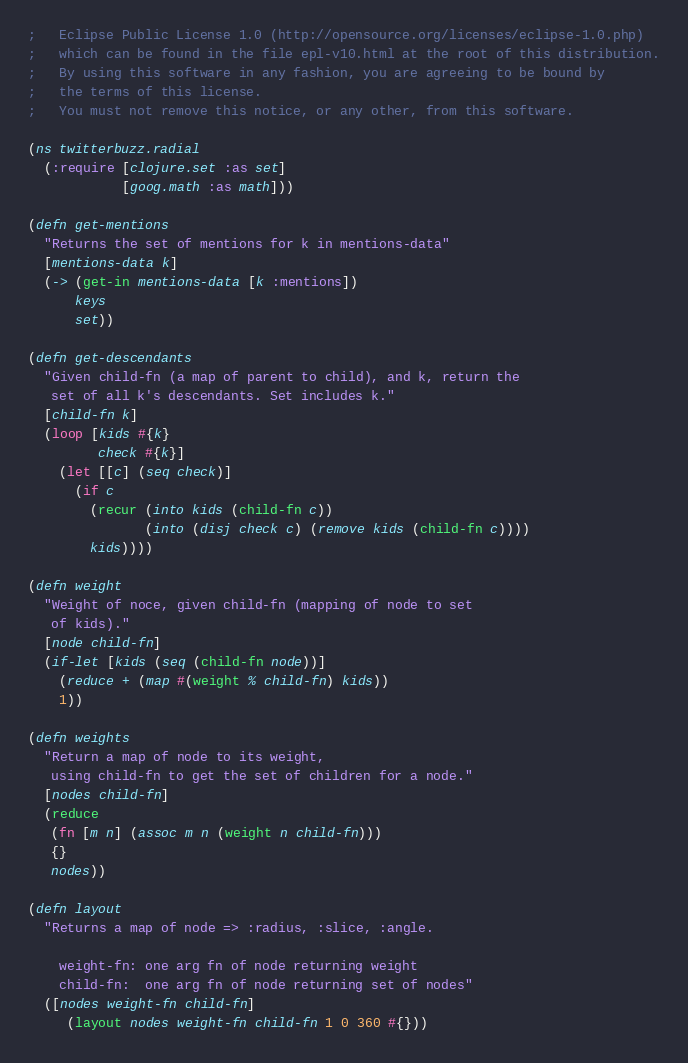Convert code to text. <code><loc_0><loc_0><loc_500><loc_500><_Clojure_>;   Eclipse Public License 1.0 (http://opensource.org/licenses/eclipse-1.0.php)
;   which can be found in the file epl-v10.html at the root of this distribution.
;   By using this software in any fashion, you are agreeing to be bound by
;   the terms of this license.
;   You must not remove this notice, or any other, from this software.

(ns twitterbuzz.radial
  (:require [clojure.set :as set]
            [goog.math :as math]))

(defn get-mentions
  "Returns the set of mentions for k in mentions-data"
  [mentions-data k]
  (-> (get-in mentions-data [k :mentions])
      keys
      set))

(defn get-descendants
  "Given child-fn (a map of parent to child), and k, return the
   set of all k's descendants. Set includes k."
  [child-fn k]
  (loop [kids #{k}
         check #{k}]
    (let [[c] (seq check)]
      (if c
        (recur (into kids (child-fn c))
               (into (disj check c) (remove kids (child-fn c))))
        kids))))

(defn weight
  "Weight of noce, given child-fn (mapping of node to set
   of kids)."
  [node child-fn]
  (if-let [kids (seq (child-fn node))]
    (reduce + (map #(weight % child-fn) kids))
    1))

(defn weights
  "Return a map of node to its weight,
   using child-fn to get the set of children for a node."
  [nodes child-fn]
  (reduce
   (fn [m n] (assoc m n (weight n child-fn)))
   {}
   nodes))

(defn layout
  "Returns a map of node => :radius, :slice, :angle.

    weight-fn: one arg fn of node returning weight
    child-fn:  one arg fn of node returning set of nodes"
  ([nodes weight-fn child-fn]
     (layout nodes weight-fn child-fn 1 0 360 #{}))</code> 